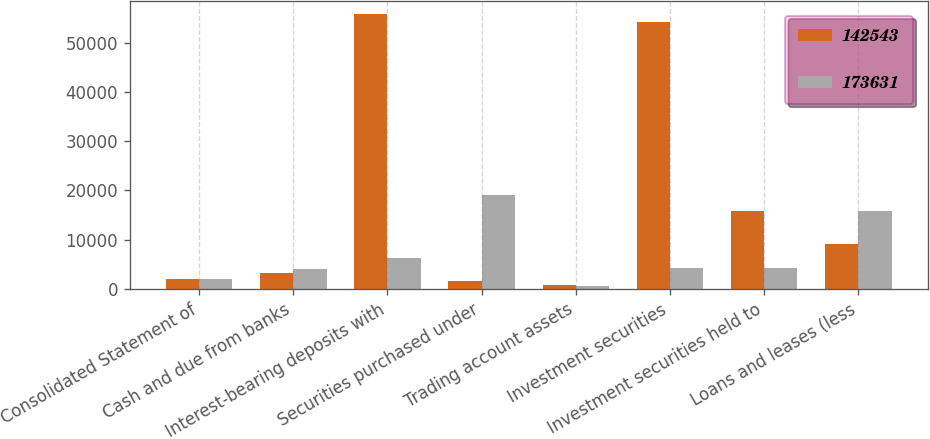<chart> <loc_0><loc_0><loc_500><loc_500><stacked_bar_chart><ecel><fcel>Consolidated Statement of<fcel>Cash and due from banks<fcel>Interest-bearing deposits with<fcel>Securities purchased under<fcel>Trading account assets<fcel>Investment securities<fcel>Investment securities held to<fcel>Loans and leases (less<nl><fcel>142543<fcel>2008<fcel>3181<fcel>55733<fcel>1635<fcel>815<fcel>54163<fcel>15767<fcel>9113<nl><fcel>173631<fcel>2007<fcel>4041<fcel>6271<fcel>19133<fcel>589<fcel>4233<fcel>4233<fcel>15784<nl></chart> 